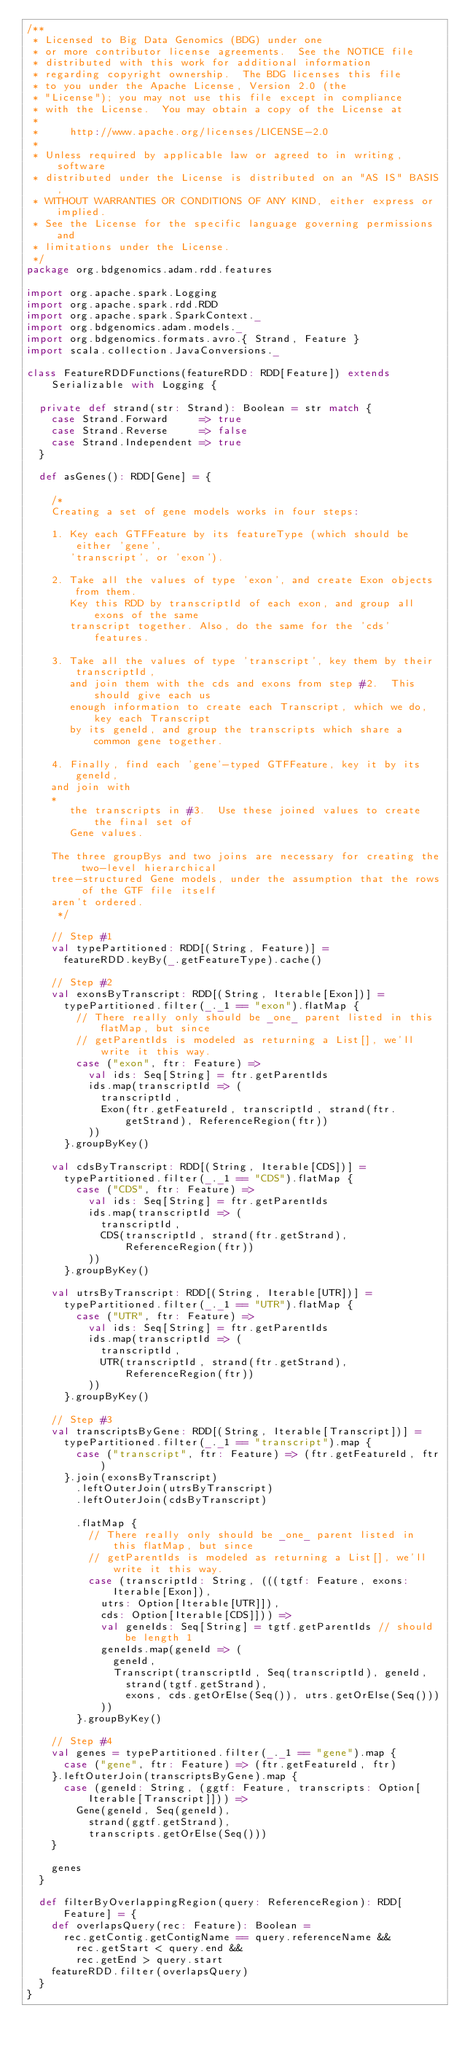Convert code to text. <code><loc_0><loc_0><loc_500><loc_500><_Scala_>/**
 * Licensed to Big Data Genomics (BDG) under one
 * or more contributor license agreements.  See the NOTICE file
 * distributed with this work for additional information
 * regarding copyright ownership.  The BDG licenses this file
 * to you under the Apache License, Version 2.0 (the
 * "License"); you may not use this file except in compliance
 * with the License.  You may obtain a copy of the License at
 *
 *     http://www.apache.org/licenses/LICENSE-2.0
 *
 * Unless required by applicable law or agreed to in writing, software
 * distributed under the License is distributed on an "AS IS" BASIS,
 * WITHOUT WARRANTIES OR CONDITIONS OF ANY KIND, either express or implied.
 * See the License for the specific language governing permissions and
 * limitations under the License.
 */
package org.bdgenomics.adam.rdd.features

import org.apache.spark.Logging
import org.apache.spark.rdd.RDD
import org.apache.spark.SparkContext._
import org.bdgenomics.adam.models._
import org.bdgenomics.formats.avro.{ Strand, Feature }
import scala.collection.JavaConversions._

class FeatureRDDFunctions(featureRDD: RDD[Feature]) extends Serializable with Logging {

  private def strand(str: Strand): Boolean = str match {
    case Strand.Forward     => true
    case Strand.Reverse     => false
    case Strand.Independent => true
  }

  def asGenes(): RDD[Gene] = {

    /*
    Creating a set of gene models works in four steps:

    1. Key each GTFFeature by its featureType (which should be either 'gene',
       'transcript', or 'exon').

    2. Take all the values of type 'exon', and create Exon objects from them.
       Key this RDD by transcriptId of each exon, and group all exons of the same
       transcript together. Also, do the same for the 'cds' features.

    3. Take all the values of type 'transcript', key them by their transcriptId,
       and join them with the cds and exons from step #2.  This should give each us
       enough information to create each Transcript, which we do, key each Transcript
       by its geneId, and group the transcripts which share a common gene together.

    4. Finally, find each 'gene'-typed GTFFeature, key it by its geneId,
    and join with
    *
       the transcripts in #3.  Use these joined values to create the final set of
       Gene values.

    The three groupBys and two joins are necessary for creating the two-level hierarchical
    tree-structured Gene models, under the assumption that the rows of the GTF file itself
    aren't ordered.
     */

    // Step #1
    val typePartitioned: RDD[(String, Feature)] =
      featureRDD.keyBy(_.getFeatureType).cache()

    // Step #2
    val exonsByTranscript: RDD[(String, Iterable[Exon])] =
      typePartitioned.filter(_._1 == "exon").flatMap {
        // There really only should be _one_ parent listed in this flatMap, but since
        // getParentIds is modeled as returning a List[], we'll write it this way.
        case ("exon", ftr: Feature) =>
          val ids: Seq[String] = ftr.getParentIds
          ids.map(transcriptId => (
            transcriptId,
            Exon(ftr.getFeatureId, transcriptId, strand(ftr.getStrand), ReferenceRegion(ftr))
          ))
      }.groupByKey()

    val cdsByTranscript: RDD[(String, Iterable[CDS])] =
      typePartitioned.filter(_._1 == "CDS").flatMap {
        case ("CDS", ftr: Feature) =>
          val ids: Seq[String] = ftr.getParentIds
          ids.map(transcriptId => (
            transcriptId,
            CDS(transcriptId, strand(ftr.getStrand), ReferenceRegion(ftr))
          ))
      }.groupByKey()

    val utrsByTranscript: RDD[(String, Iterable[UTR])] =
      typePartitioned.filter(_._1 == "UTR").flatMap {
        case ("UTR", ftr: Feature) =>
          val ids: Seq[String] = ftr.getParentIds
          ids.map(transcriptId => (
            transcriptId,
            UTR(transcriptId, strand(ftr.getStrand), ReferenceRegion(ftr))
          ))
      }.groupByKey()

    // Step #3
    val transcriptsByGene: RDD[(String, Iterable[Transcript])] =
      typePartitioned.filter(_._1 == "transcript").map {
        case ("transcript", ftr: Feature) => (ftr.getFeatureId, ftr)
      }.join(exonsByTranscript)
        .leftOuterJoin(utrsByTranscript)
        .leftOuterJoin(cdsByTranscript)

        .flatMap {
          // There really only should be _one_ parent listed in this flatMap, but since
          // getParentIds is modeled as returning a List[], we'll write it this way.
          case (transcriptId: String, (((tgtf: Feature, exons: Iterable[Exon]),
            utrs: Option[Iterable[UTR]]),
            cds: Option[Iterable[CDS]])) =>
            val geneIds: Seq[String] = tgtf.getParentIds // should be length 1
            geneIds.map(geneId => (
              geneId,
              Transcript(transcriptId, Seq(transcriptId), geneId,
                strand(tgtf.getStrand),
                exons, cds.getOrElse(Seq()), utrs.getOrElse(Seq()))
            ))
        }.groupByKey()

    // Step #4
    val genes = typePartitioned.filter(_._1 == "gene").map {
      case ("gene", ftr: Feature) => (ftr.getFeatureId, ftr)
    }.leftOuterJoin(transcriptsByGene).map {
      case (geneId: String, (ggtf: Feature, transcripts: Option[Iterable[Transcript]])) =>
        Gene(geneId, Seq(geneId),
          strand(ggtf.getStrand),
          transcripts.getOrElse(Seq()))
    }

    genes
  }

  def filterByOverlappingRegion(query: ReferenceRegion): RDD[Feature] = {
    def overlapsQuery(rec: Feature): Boolean =
      rec.getContig.getContigName == query.referenceName &&
        rec.getStart < query.end &&
        rec.getEnd > query.start
    featureRDD.filter(overlapsQuery)
  }
}
</code> 